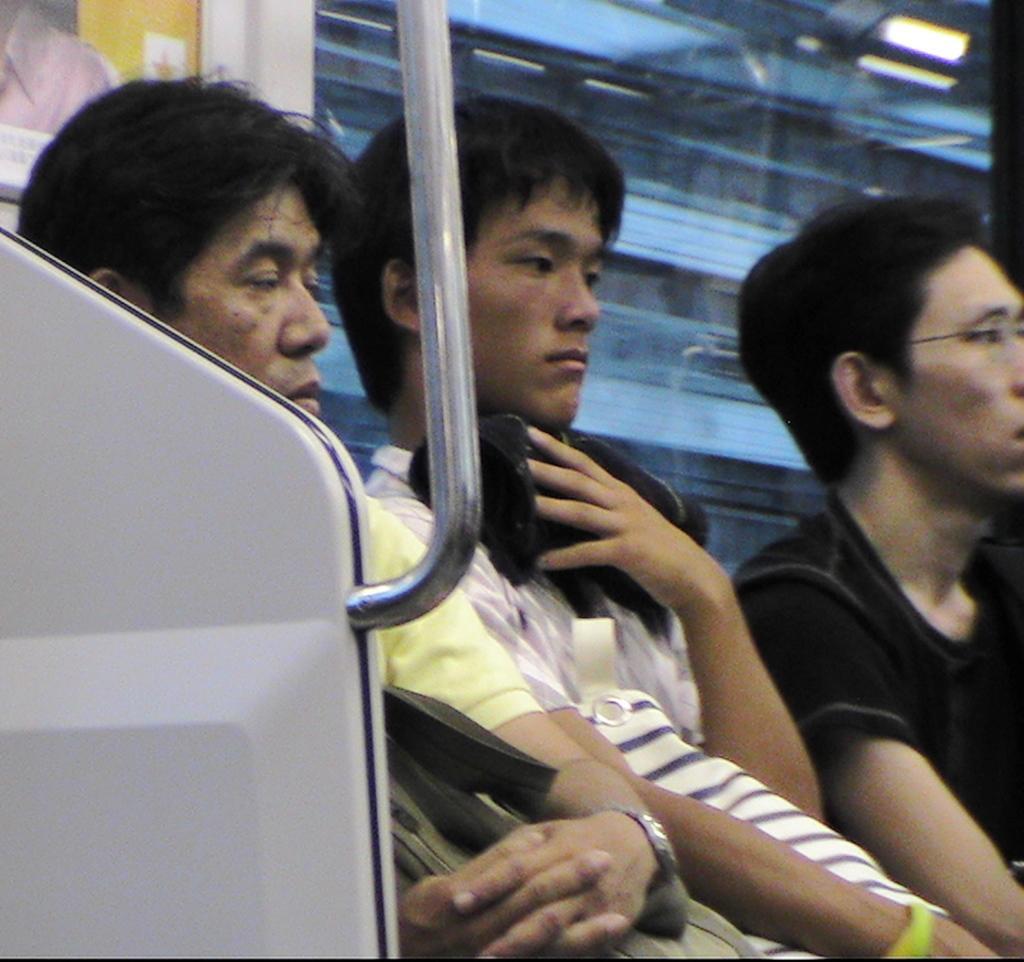Describe this image in one or two sentences. In this image we can see three men sitting. In that a man is holding an object. We can also see a metal pole and a glass window. 